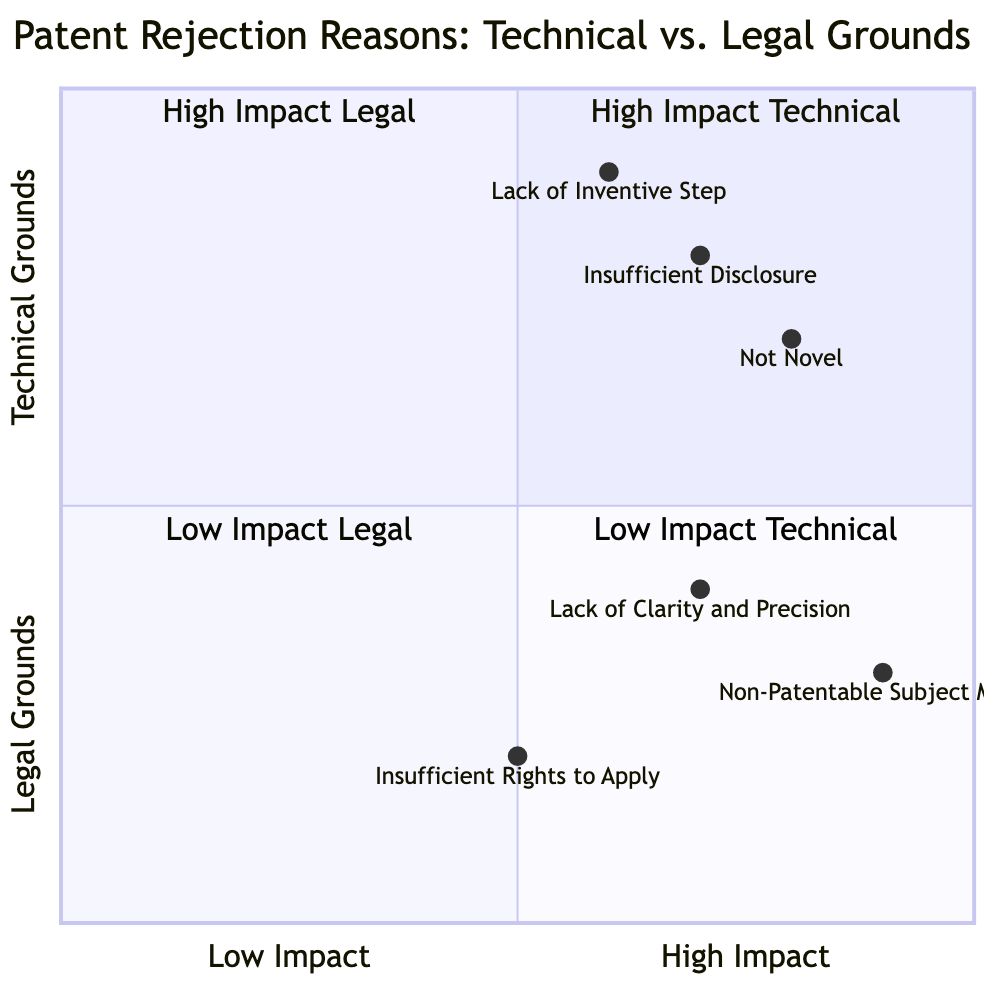What is the y-axis label of the diagram? The y-axis label represents the classification of the rejection reasons. It is defined as "Legal Grounds --> Technical Grounds."
Answer: Legal Grounds --> Technical Grounds Which rejection reason is positioned at the coordinates [0.5, 0.2]? To find which reason occupies these coordinates, we look at the list of rejection reasons and their corresponding coordinates. The coordinates [0.5, 0.2] represent "Insufficient Rights to Apply."
Answer: Insufficient Rights to Apply How many rejection reasons are classified under Technical Grounds? The diagram classifies three rejection reasons under Technical Grounds: "Insufficient Disclosure," "Lack of Inventive Step," and "Not Novel." Thus, the total count is three.
Answer: 3 Which rejection reason has the highest Y-axis value? Examining the given coordinates for each rejection reason, "Lack of Inventive Step," at [0.6, 0.9], has the highest Y-axis value of 0.9.
Answer: Lack of Inventive Step Are there more High Impact technical reasons or High Impact legal reasons? The diagram indicates there are three High Impact technical reasons: "Insufficient Disclosure," "Lack of Inventive Step," and "Not Novel," while there is one High Impact legal reason: "Non-Patentable Subject Matter." Therefore, High Impact technical reasons are more numerous.
Answer: High Impact technical reasons Which quadrant contains "Non-Patentable Subject Matter"? To identify the quadrant for "Non-Patentable Subject Matter," we refer to its coordinates [0.9, 0.3]. This places it in Quadrant 2, which is labeled "High Impact Legal."
Answer: Quadrant 2 What is the overall impact of the reason "Not Novel"? The coordinates for "Not Novel" are [0.8, 0.7], indicating it has a high impact on technical grounds. The impact is high as its coordinates are closer to the High Impact section of the diagram.
Answer: High Impact Which range does the "Lack of Clarity and Precision" fall under regarding its technical impact? The coordinates for "Lack of Clarity and Precision" are [0.7, 0.4]. Here, the X-axis value of 0.7 indicates it falls within the medium range of technical impact.
Answer: Medium range What does the X-axis represent in terms of impact? The X-axis represents the range of impact classified as "Low Impact --> High Impact," showing how significantly each rejection reason affects the patent application process.
Answer: Low Impact --> High Impact 